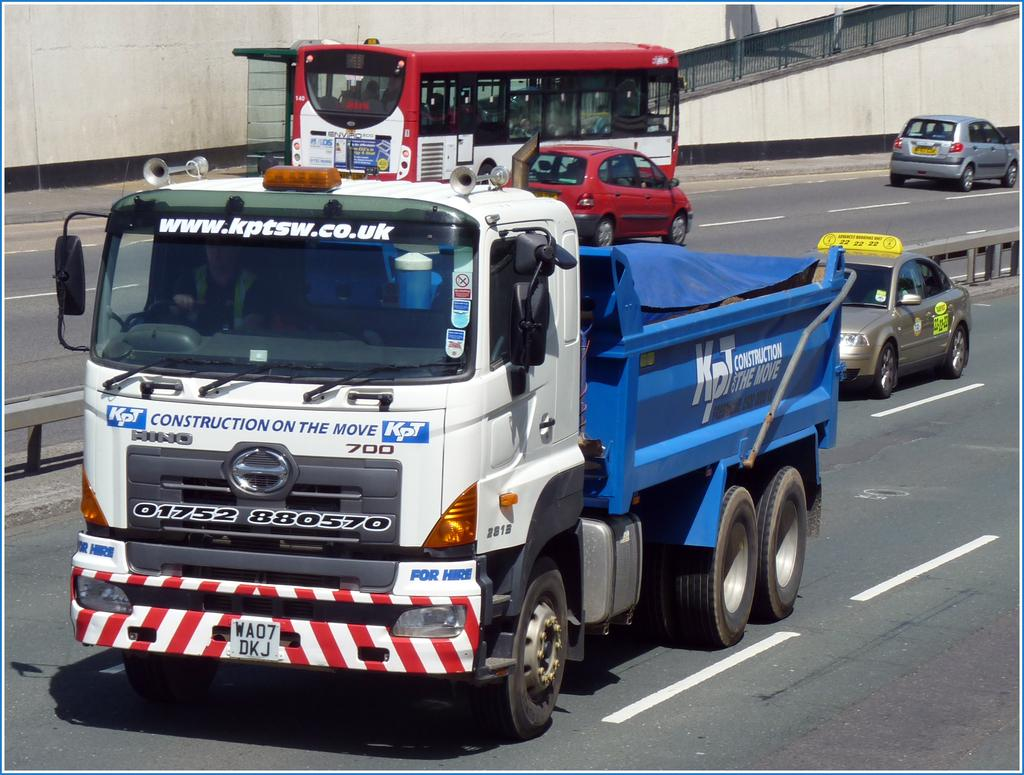<image>
Describe the image concisely. A white and blue dump trump is going down a highway and says Construction on the Move on the front. 